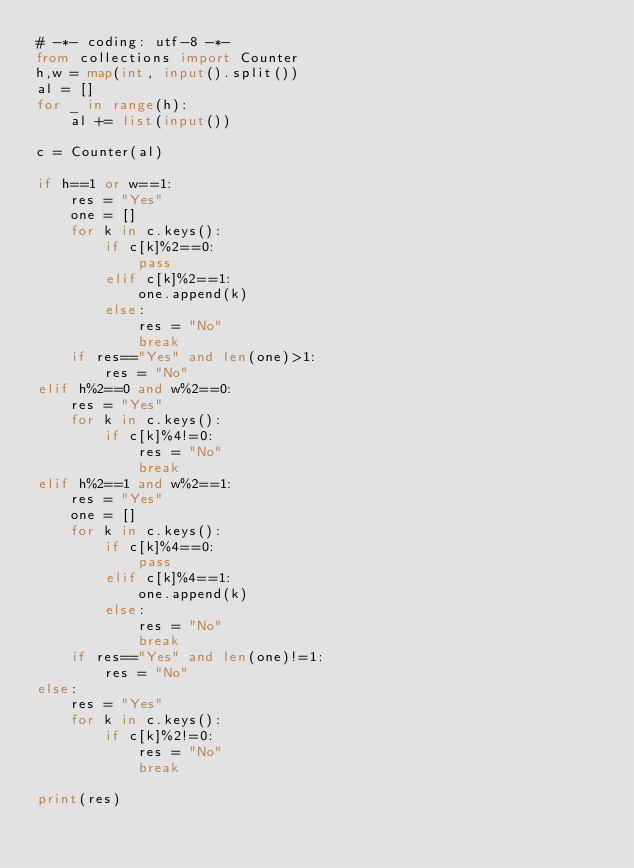Convert code to text. <code><loc_0><loc_0><loc_500><loc_500><_Python_># -*- coding: utf-8 -*-
from collections import Counter
h,w = map(int, input().split())
al = []
for _ in range(h):
    al += list(input())

c = Counter(al)

if h==1 or w==1:
    res = "Yes"
    one = []
    for k in c.keys():
        if c[k]%2==0:
            pass
        elif c[k]%2==1:
            one.append(k)
        else:
            res = "No"
            break
    if res=="Yes" and len(one)>1:
        res = "No"
elif h%2==0 and w%2==0:
    res = "Yes"
    for k in c.keys():
        if c[k]%4!=0:
            res = "No"
            break
elif h%2==1 and w%2==1:
    res = "Yes"
    one = []
    for k in c.keys():
        if c[k]%4==0:
            pass
        elif c[k]%4==1:
            one.append(k)
        else:
            res = "No"
            break
    if res=="Yes" and len(one)!=1:
        res = "No"
else:
    res = "Yes"
    for k in c.keys():
        if c[k]%2!=0:
            res = "No"
            break

print(res)
</code> 